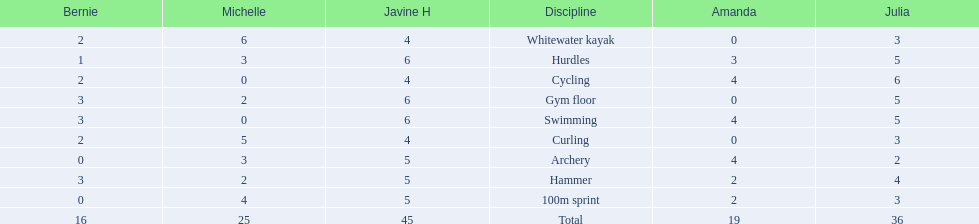Name a girl that had the same score in cycling and archery. Amanda. Could you help me parse every detail presented in this table? {'header': ['Bernie', 'Michelle', 'Javine H', 'Discipline', 'Amanda', 'Julia'], 'rows': [['2', '6', '4', 'Whitewater kayak', '0', '3'], ['1', '3', '6', 'Hurdles', '3', '5'], ['2', '0', '4', 'Cycling', '4', '6'], ['3', '2', '6', 'Gym floor', '0', '5'], ['3', '0', '6', 'Swimming', '4', '5'], ['2', '5', '4', 'Curling', '0', '3'], ['0', '3', '5', 'Archery', '4', '2'], ['3', '2', '5', 'Hammer', '2', '4'], ['0', '4', '5', '100m sprint', '2', '3'], ['16', '25', '45', 'Total', '19', '36']]} 